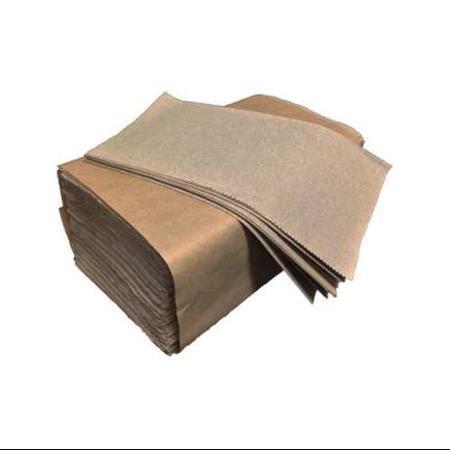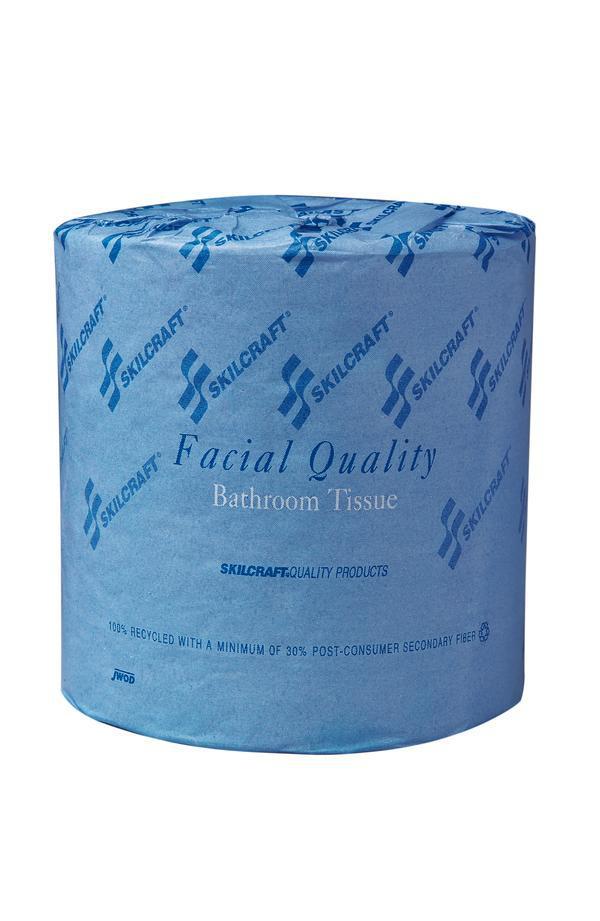The first image is the image on the left, the second image is the image on the right. Analyze the images presented: Is the assertion "At least one of the paper products is available by the roll." valid? Answer yes or no. Yes. The first image is the image on the left, the second image is the image on the right. Assess this claim about the two images: "No paper rolls are shown, but a stack of folded towels in a brown wrapper and a cardboard box are shown.". Correct or not? Answer yes or no. No. 